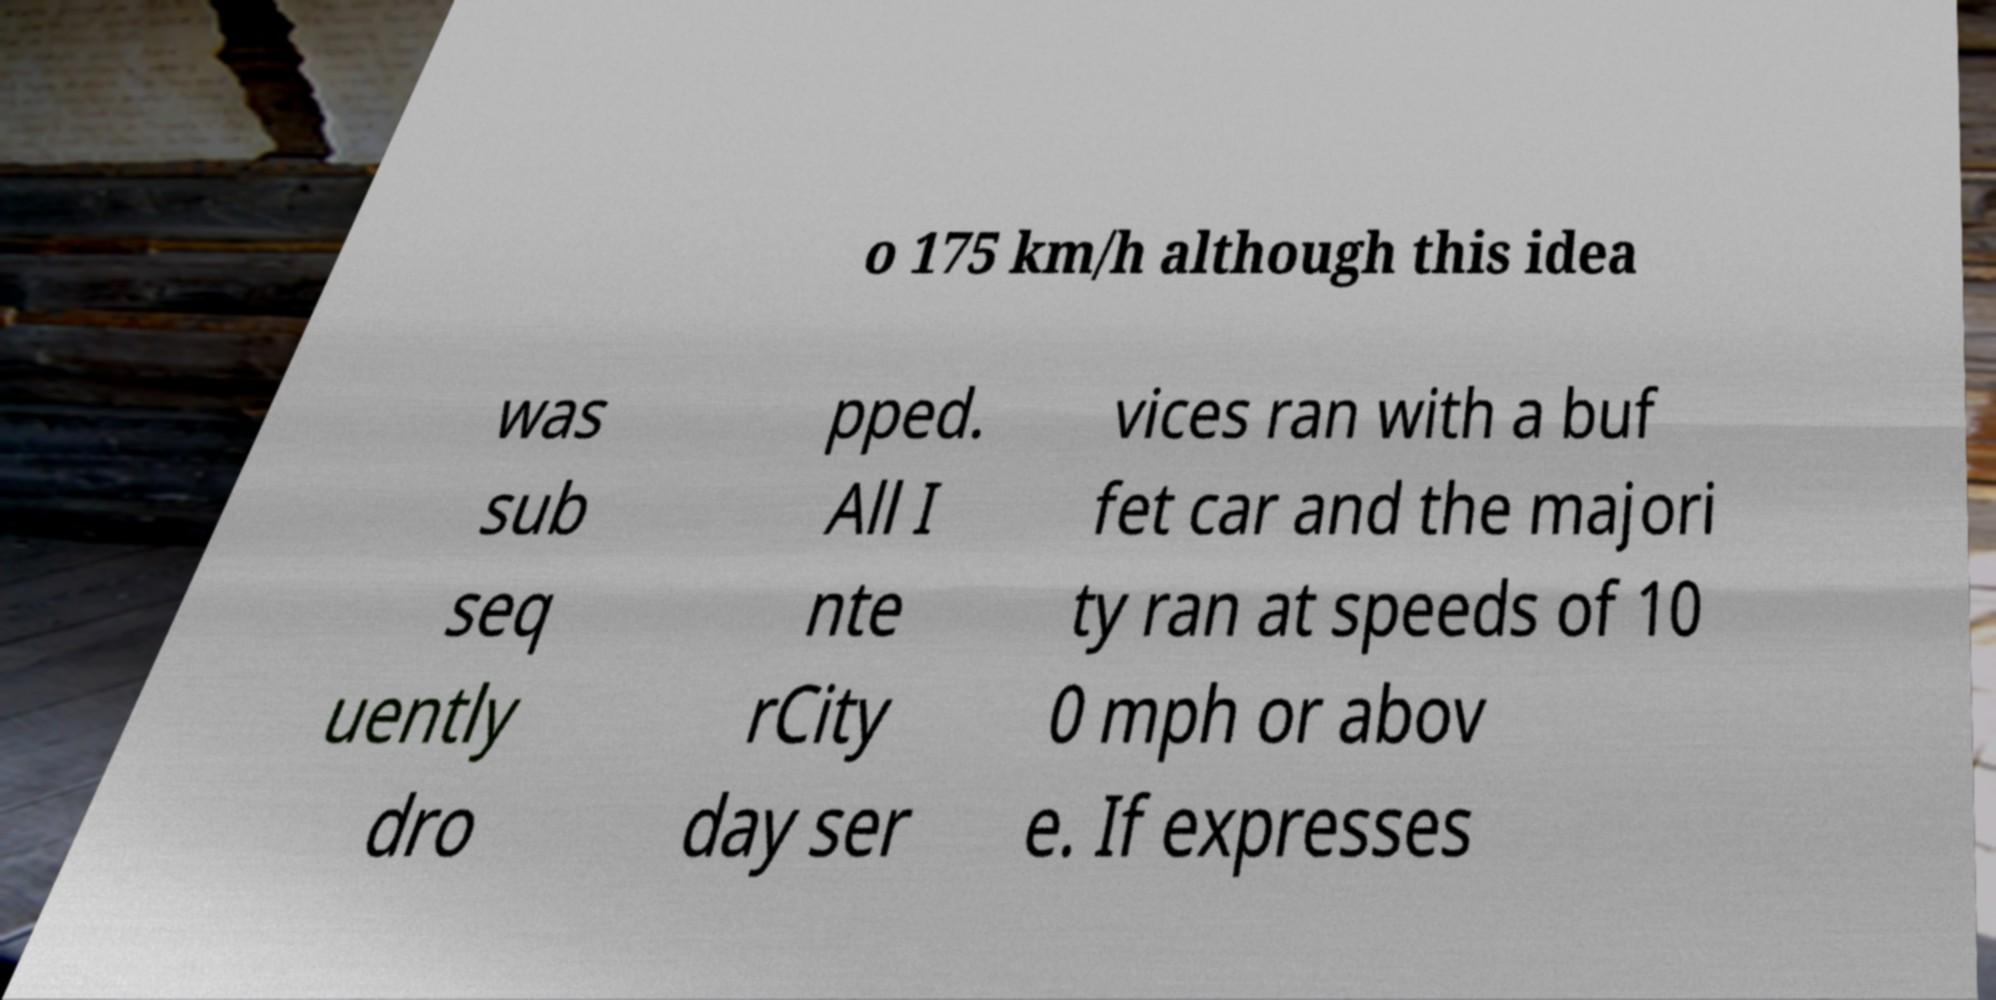Can you read and provide the text displayed in the image?This photo seems to have some interesting text. Can you extract and type it out for me? o 175 km/h although this idea was sub seq uently dro pped. All I nte rCity day ser vices ran with a buf fet car and the majori ty ran at speeds of 10 0 mph or abov e. If expresses 